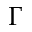<formula> <loc_0><loc_0><loc_500><loc_500>\Gamma</formula> 